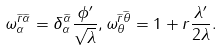Convert formula to latex. <formula><loc_0><loc_0><loc_500><loc_500>\omega _ { \alpha } ^ { \widetilde { r } \widetilde { \alpha } } = \delta _ { \alpha } ^ { \widetilde { \alpha } } \frac { \phi ^ { \prime } } { \sqrt { \lambda } } , \omega _ { \theta } ^ { \widetilde { r } \widetilde { \theta } } = 1 + r \frac { \lambda ^ { \prime } } { 2 \lambda } .</formula> 